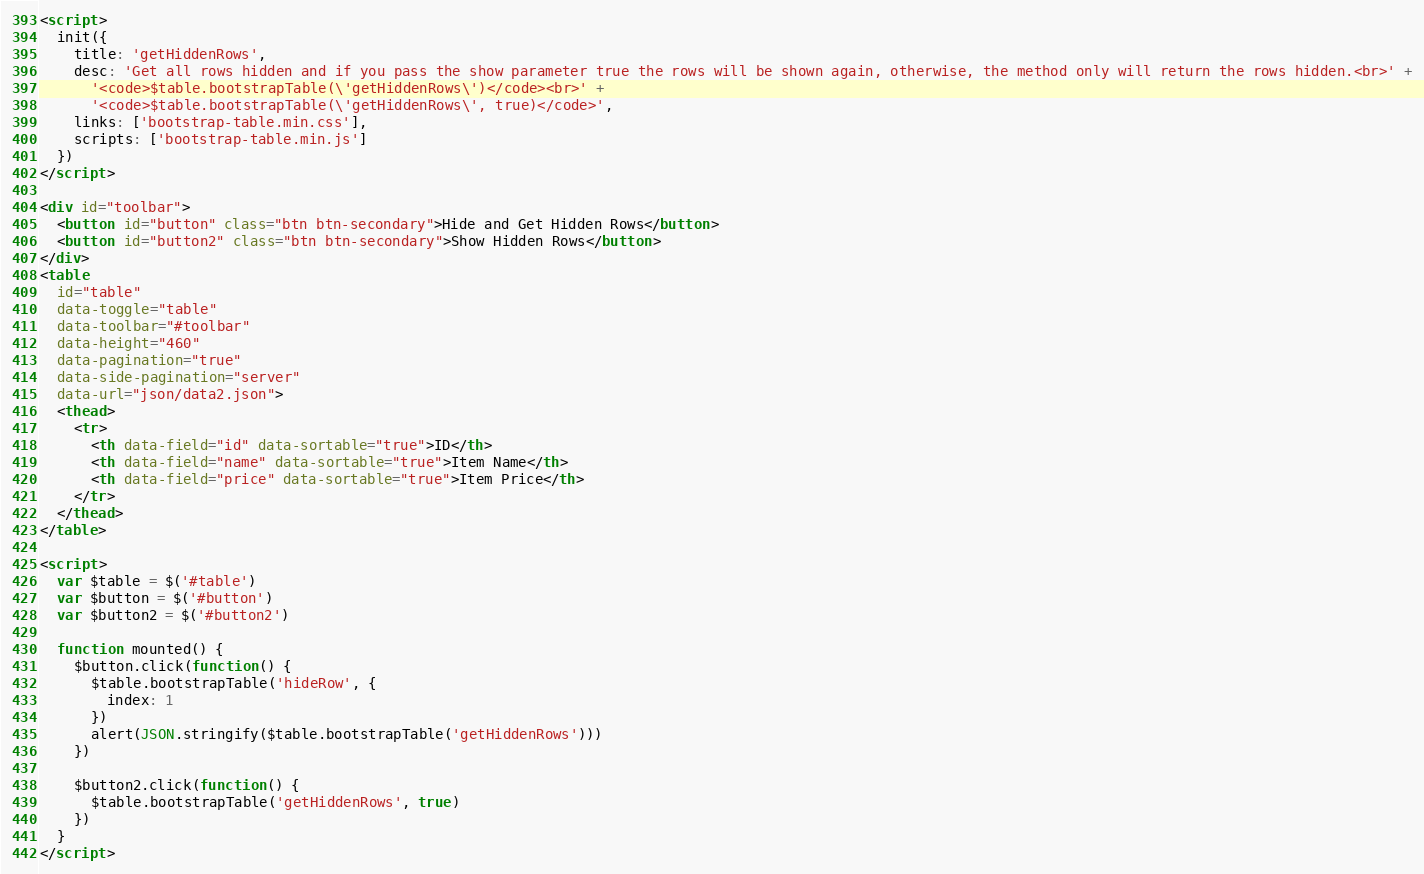<code> <loc_0><loc_0><loc_500><loc_500><_HTML_><script>
  init({
    title: 'getHiddenRows',
    desc: 'Get all rows hidden and if you pass the show parameter true the rows will be shown again, otherwise, the method only will return the rows hidden.<br>' +
      '<code>$table.bootstrapTable(\'getHiddenRows\')</code><br>' +
      '<code>$table.bootstrapTable(\'getHiddenRows\', true)</code>',
    links: ['bootstrap-table.min.css'],
    scripts: ['bootstrap-table.min.js']
  })
</script>

<div id="toolbar">
  <button id="button" class="btn btn-secondary">Hide and Get Hidden Rows</button>
  <button id="button2" class="btn btn-secondary">Show Hidden Rows</button>
</div>
<table
  id="table"
  data-toggle="table"
  data-toolbar="#toolbar"
  data-height="460"
  data-pagination="true"
  data-side-pagination="server"
  data-url="json/data2.json">
  <thead>
    <tr>
      <th data-field="id" data-sortable="true">ID</th>
      <th data-field="name" data-sortable="true">Item Name</th>
      <th data-field="price" data-sortable="true">Item Price</th>
    </tr>
  </thead>
</table>

<script>
  var $table = $('#table')
  var $button = $('#button')
  var $button2 = $('#button2')

  function mounted() {
    $button.click(function() {
      $table.bootstrapTable('hideRow', {
        index: 1
      })
      alert(JSON.stringify($table.bootstrapTable('getHiddenRows')))
    })

    $button2.click(function() {
      $table.bootstrapTable('getHiddenRows', true)
    })
  }
</script>
</code> 